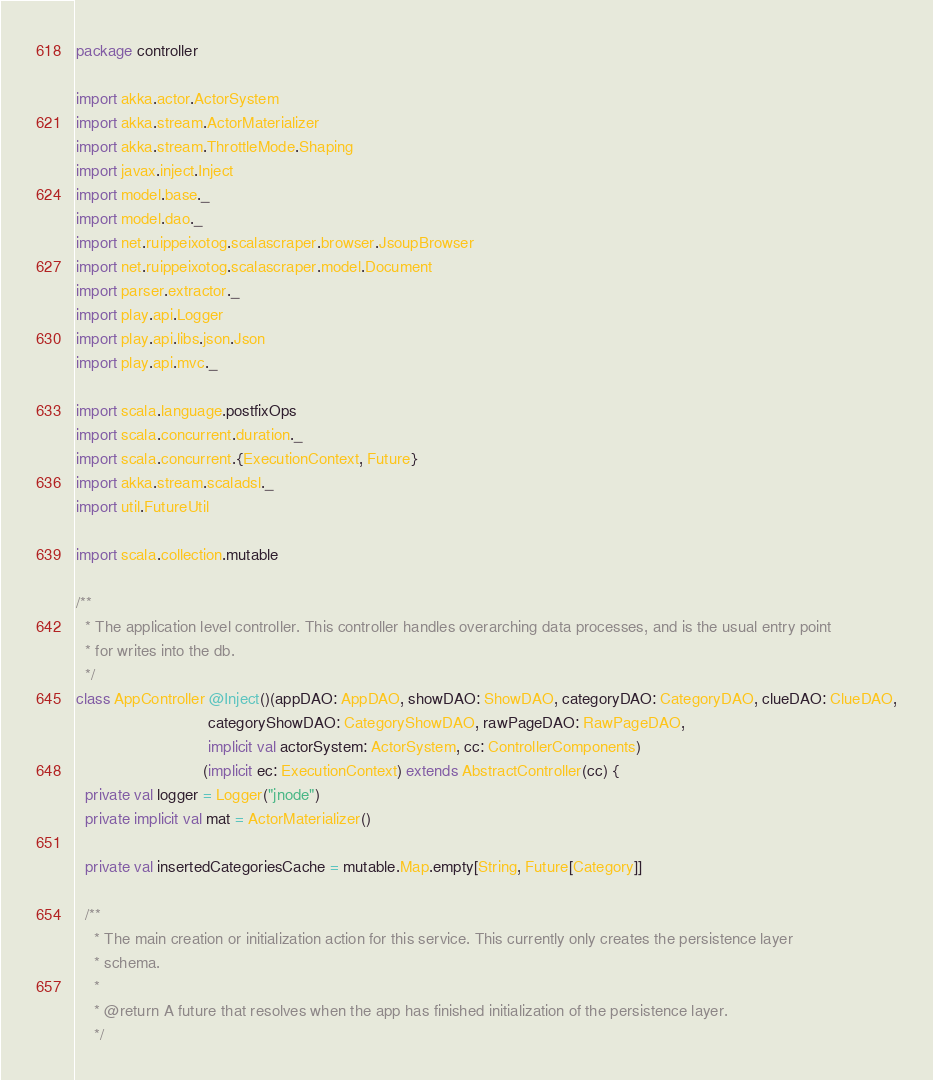Convert code to text. <code><loc_0><loc_0><loc_500><loc_500><_Scala_>package controller

import akka.actor.ActorSystem
import akka.stream.ActorMaterializer
import akka.stream.ThrottleMode.Shaping
import javax.inject.Inject
import model.base._
import model.dao._
import net.ruippeixotog.scalascraper.browser.JsoupBrowser
import net.ruippeixotog.scalascraper.model.Document
import parser.extractor._
import play.api.Logger
import play.api.libs.json.Json
import play.api.mvc._

import scala.language.postfixOps
import scala.concurrent.duration._
import scala.concurrent.{ExecutionContext, Future}
import akka.stream.scaladsl._
import util.FutureUtil

import scala.collection.mutable

/**
  * The application level controller. This controller handles overarching data processes, and is the usual entry point
  * for writes into the db.
  */
class AppController @Inject()(appDAO: AppDAO, showDAO: ShowDAO, categoryDAO: CategoryDAO, clueDAO: ClueDAO,
                              categoryShowDAO: CategoryShowDAO, rawPageDAO: RawPageDAO,
                              implicit val actorSystem: ActorSystem, cc: ControllerComponents)
                             (implicit ec: ExecutionContext) extends AbstractController(cc) {
  private val logger = Logger("jnode")
  private implicit val mat = ActorMaterializer()

  private val insertedCategoriesCache = mutable.Map.empty[String, Future[Category]]

  /**
    * The main creation or initialization action for this service. This currently only creates the persistence layer
    * schema.
    *
    * @return A future that resolves when the app has finished initialization of the persistence layer.
    */</code> 